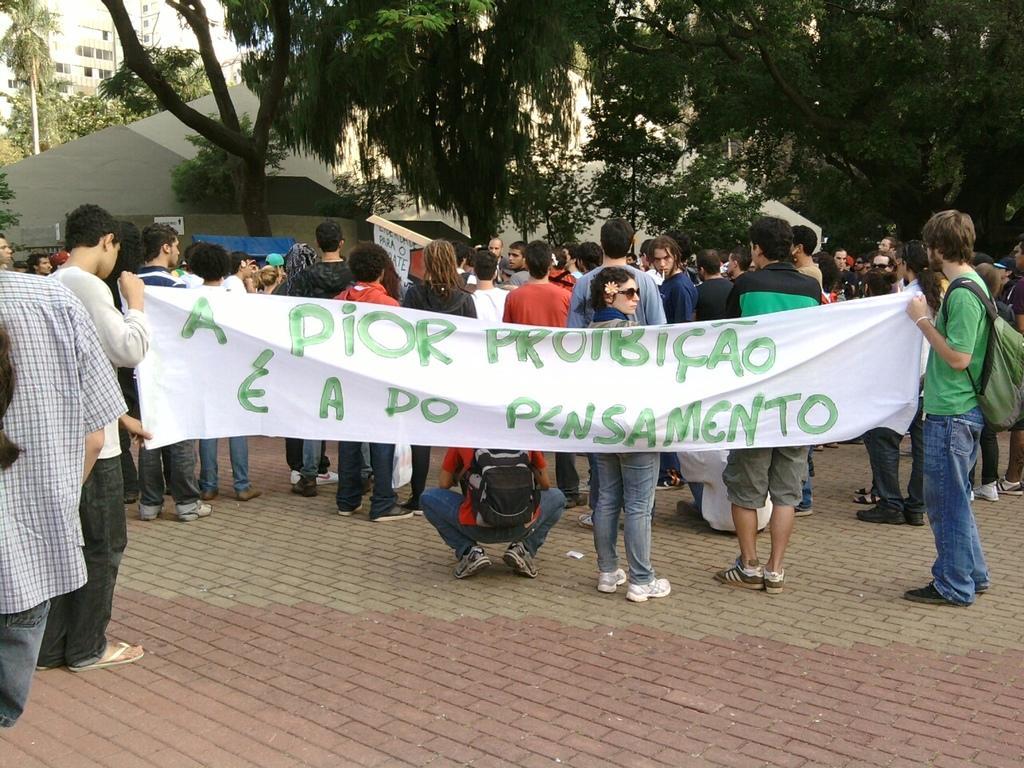Can you describe this image briefly? In this picture we can see a group of people on the ground, some people are wearing bags, some people are holding a banner and in the background we can see buildings, trees and some objects. 